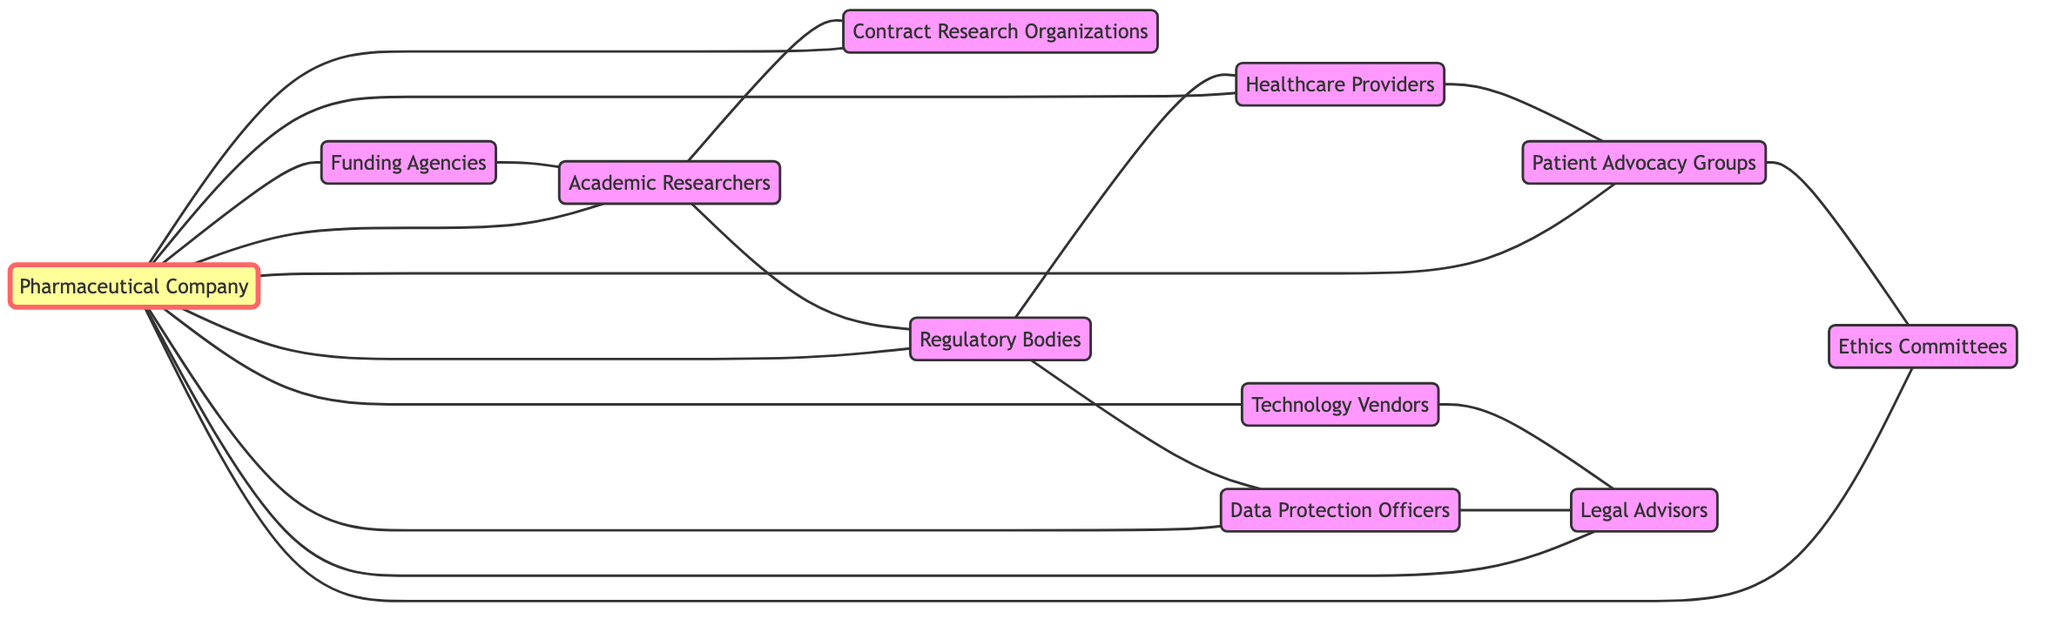What is the total number of nodes in the diagram? The diagram lists the following nodes: Pharmaceutical Company, Academic Researchers, Contract Research Organizations, Regulatory Bodies, Healthcare Providers, Data Protection Officers, Patient Advocacy Groups, Ethics Committees, Technology Vendors, Legal Advisors, and Funding Agencies. Counting these gives a total of 11 nodes.
Answer: 11 Which node has the highest number of connections? By examining the edges, we can see that the Pharmaceutical Company connects to 10 other nodes, making it the most connected node in the diagram.
Answer: Pharmaceutical Company How many edges are there in total? The edges between the nodes are counted directly from the provided data, totaling 17 connections between the nodes.
Answer: 17 Which two nodes are connected through the edge that includes Healthcare Providers? We observe the edge connections and see that Healthcare Providers are connected to Regulatory Bodies and Patient Advocacy Groups. Therefore, the two nodes connected through this edge are Regulatory Bodies and Patient Advocacy Groups.
Answer: Regulatory Bodies, Patient Advocacy Groups What is the connection between Data Protection Officers and Legal Advisors? The diagram shows a direct edge between Data Protection Officers and Legal Advisors, indicating a partnership or collaboration between these two stakeholders in the context of privacy in drug development.
Answer: Direct connection 